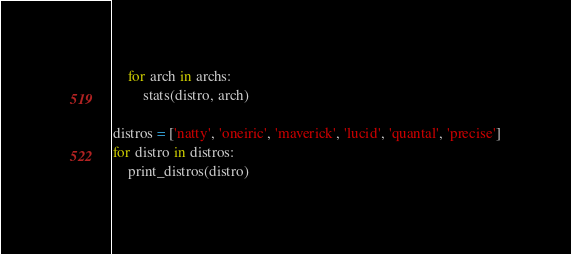Convert code to text. <code><loc_0><loc_0><loc_500><loc_500><_Python_>    for arch in archs:
        stats(distro, arch)

distros = ['natty', 'oneiric', 'maverick', 'lucid', 'quantal', 'precise']
for distro in distros:
    print_distros(distro)
</code> 